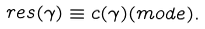Convert formula to latex. <formula><loc_0><loc_0><loc_500><loc_500>r e s ( \gamma ) \equiv c ( \gamma ) ( m o d e ) .</formula> 